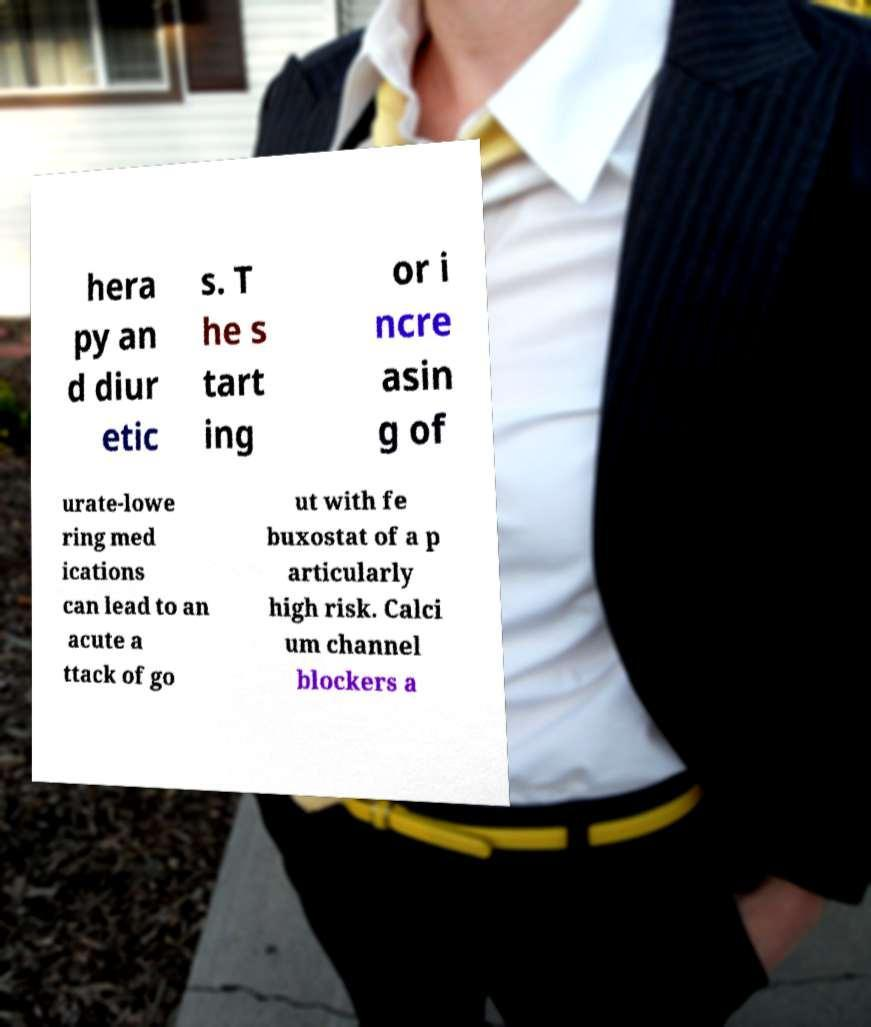What messages or text are displayed in this image? I need them in a readable, typed format. hera py an d diur etic s. T he s tart ing or i ncre asin g of urate-lowe ring med ications can lead to an acute a ttack of go ut with fe buxostat of a p articularly high risk. Calci um channel blockers a 